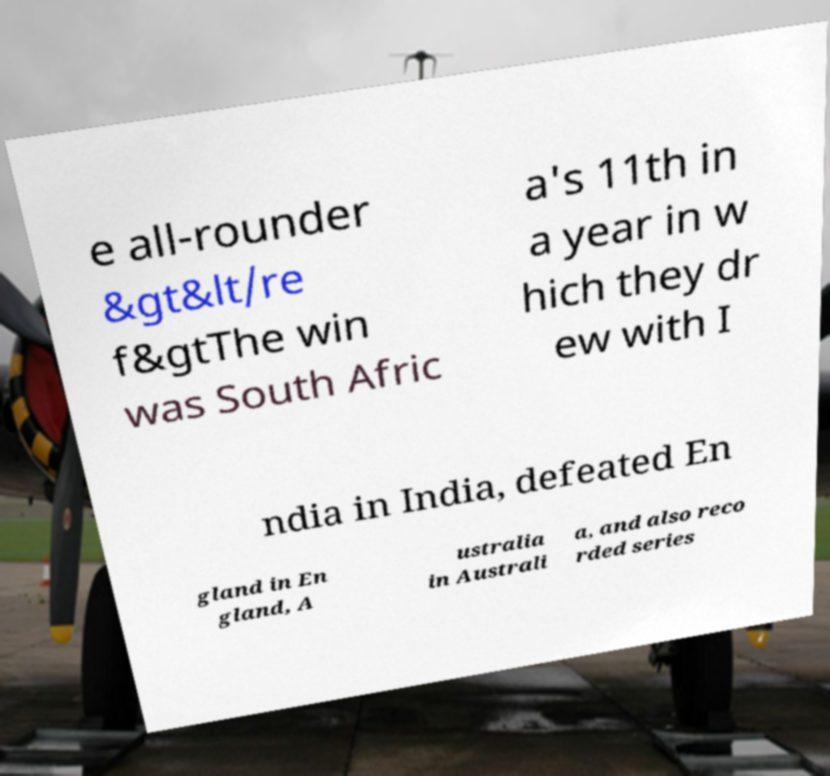Please read and relay the text visible in this image. What does it say? e all-rounder &gt&lt/re f&gtThe win was South Afric a's 11th in a year in w hich they dr ew with I ndia in India, defeated En gland in En gland, A ustralia in Australi a, and also reco rded series 